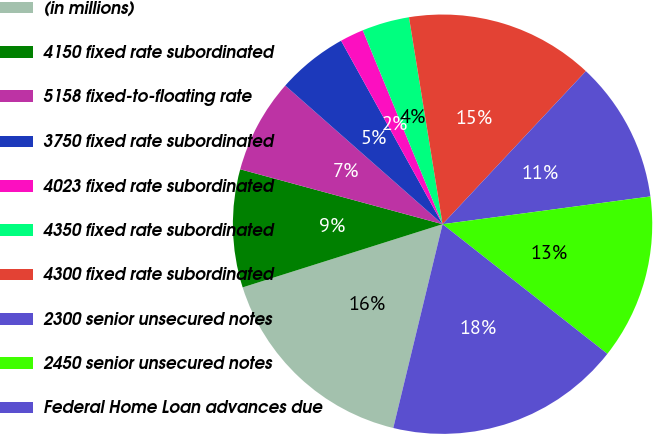Convert chart to OTSL. <chart><loc_0><loc_0><loc_500><loc_500><pie_chart><fcel>(in millions)<fcel>4150 fixed rate subordinated<fcel>5158 fixed-to-floating rate<fcel>3750 fixed rate subordinated<fcel>4023 fixed rate subordinated<fcel>4350 fixed rate subordinated<fcel>4300 fixed rate subordinated<fcel>2300 senior unsecured notes<fcel>2450 senior unsecured notes<fcel>Federal Home Loan advances due<nl><fcel>16.35%<fcel>9.09%<fcel>7.28%<fcel>5.46%<fcel>1.83%<fcel>3.65%<fcel>14.54%<fcel>10.91%<fcel>12.72%<fcel>18.17%<nl></chart> 